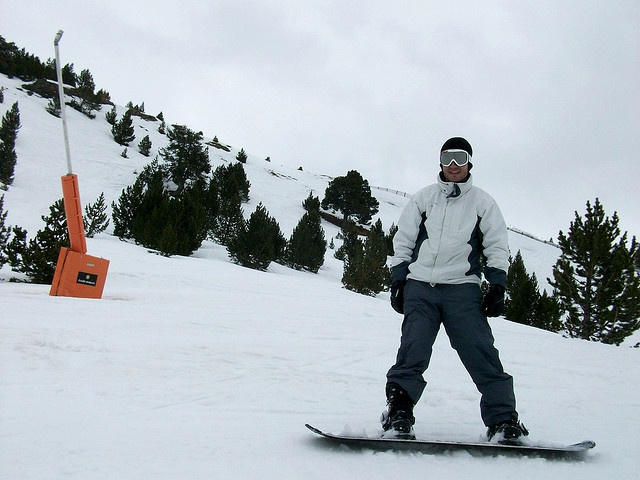Describe the objects in this image and their specific colors. I can see people in lavender, black, darkgray, lightgray, and gray tones, snowboard in lavender, black, darkgray, gray, and lightgray tones, and people in lavender, gray, black, darkgray, and lightgray tones in this image. 